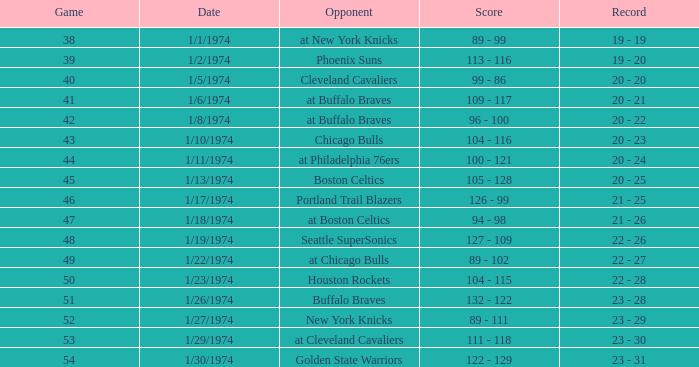What opponent played on 1/13/1974? Boston Celtics. Parse the full table. {'header': ['Game', 'Date', 'Opponent', 'Score', 'Record'], 'rows': [['38', '1/1/1974', 'at New York Knicks', '89 - 99', '19 - 19'], ['39', '1/2/1974', 'Phoenix Suns', '113 - 116', '19 - 20'], ['40', '1/5/1974', 'Cleveland Cavaliers', '99 - 86', '20 - 20'], ['41', '1/6/1974', 'at Buffalo Braves', '109 - 117', '20 - 21'], ['42', '1/8/1974', 'at Buffalo Braves', '96 - 100', '20 - 22'], ['43', '1/10/1974', 'Chicago Bulls', '104 - 116', '20 - 23'], ['44', '1/11/1974', 'at Philadelphia 76ers', '100 - 121', '20 - 24'], ['45', '1/13/1974', 'Boston Celtics', '105 - 128', '20 - 25'], ['46', '1/17/1974', 'Portland Trail Blazers', '126 - 99', '21 - 25'], ['47', '1/18/1974', 'at Boston Celtics', '94 - 98', '21 - 26'], ['48', '1/19/1974', 'Seattle SuperSonics', '127 - 109', '22 - 26'], ['49', '1/22/1974', 'at Chicago Bulls', '89 - 102', '22 - 27'], ['50', '1/23/1974', 'Houston Rockets', '104 - 115', '22 - 28'], ['51', '1/26/1974', 'Buffalo Braves', '132 - 122', '23 - 28'], ['52', '1/27/1974', 'New York Knicks', '89 - 111', '23 - 29'], ['53', '1/29/1974', 'at Cleveland Cavaliers', '111 - 118', '23 - 30'], ['54', '1/30/1974', 'Golden State Warriors', '122 - 129', '23 - 31']]} 